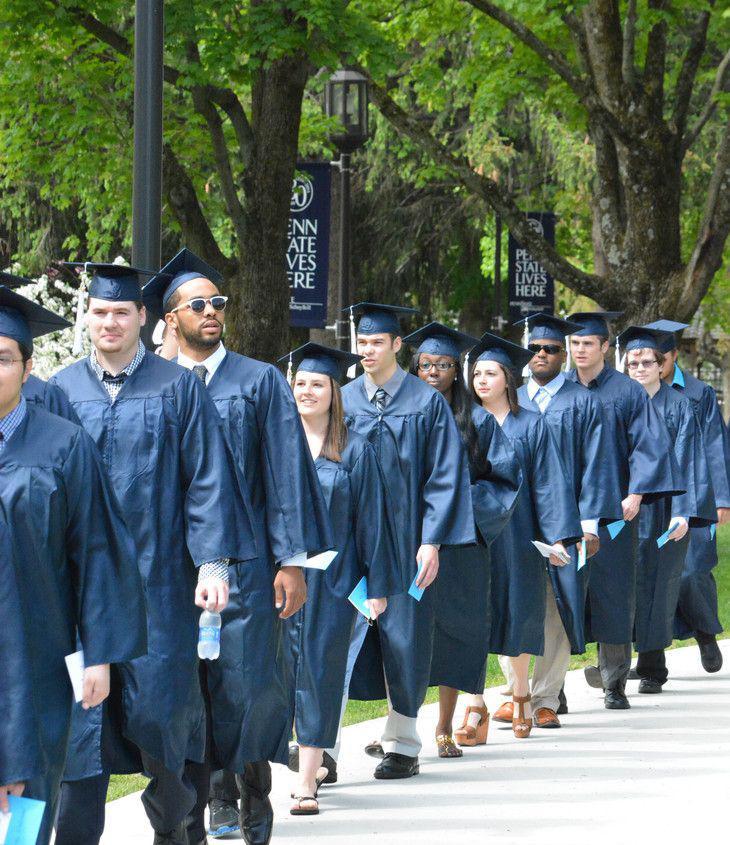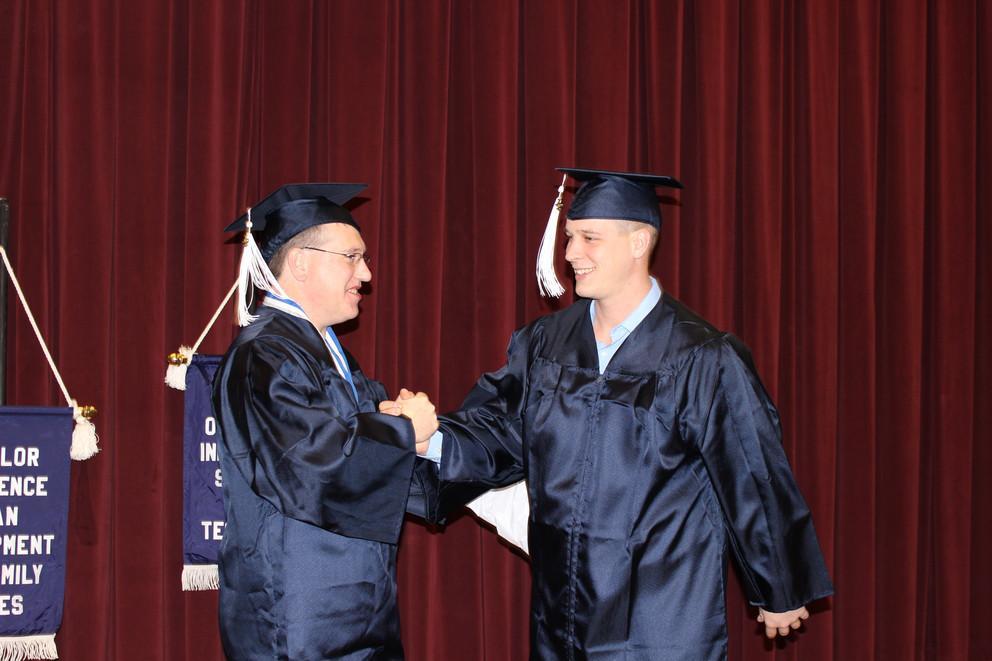The first image is the image on the left, the second image is the image on the right. For the images shown, is this caption "There is a group of students walking in a line in the left image." true? Answer yes or no. Yes. 